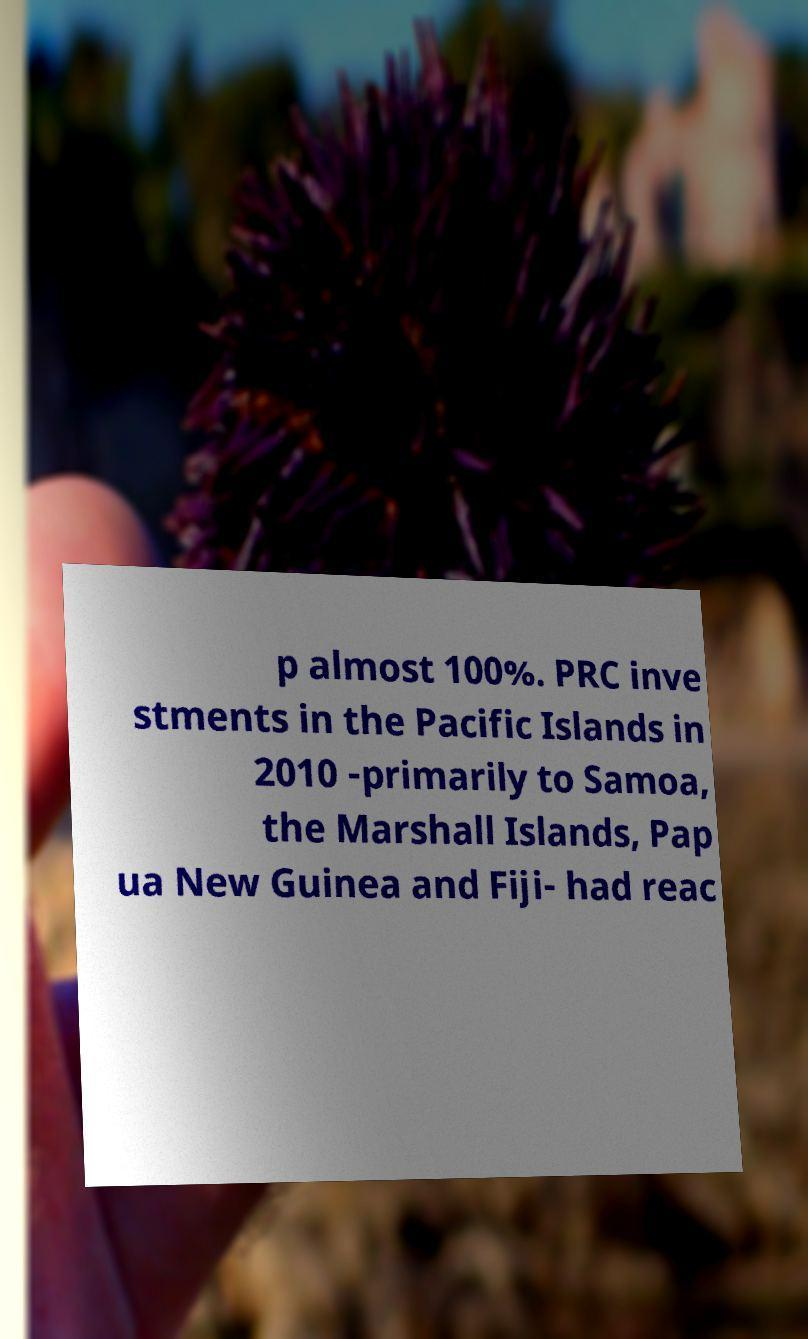For documentation purposes, I need the text within this image transcribed. Could you provide that? p almost 100%. PRC inve stments in the Pacific Islands in 2010 -primarily to Samoa, the Marshall Islands, Pap ua New Guinea and Fiji- had reac 